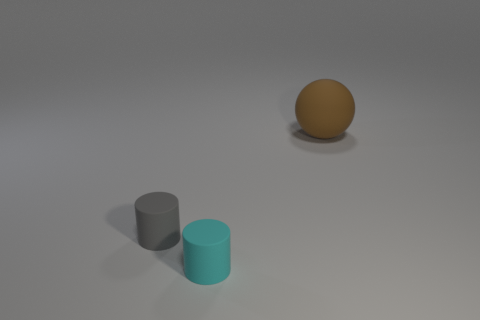What could be the texture of the objects? The objects in the image seem to have distinct textures. The gray cylinder has a rough matte finish, the cyan cylinder looks smooth with a slight reflective quality, and the brown sphere appears to have an even, non-glossy texture that might feel like a fine-grit sandpaper to the touch. 